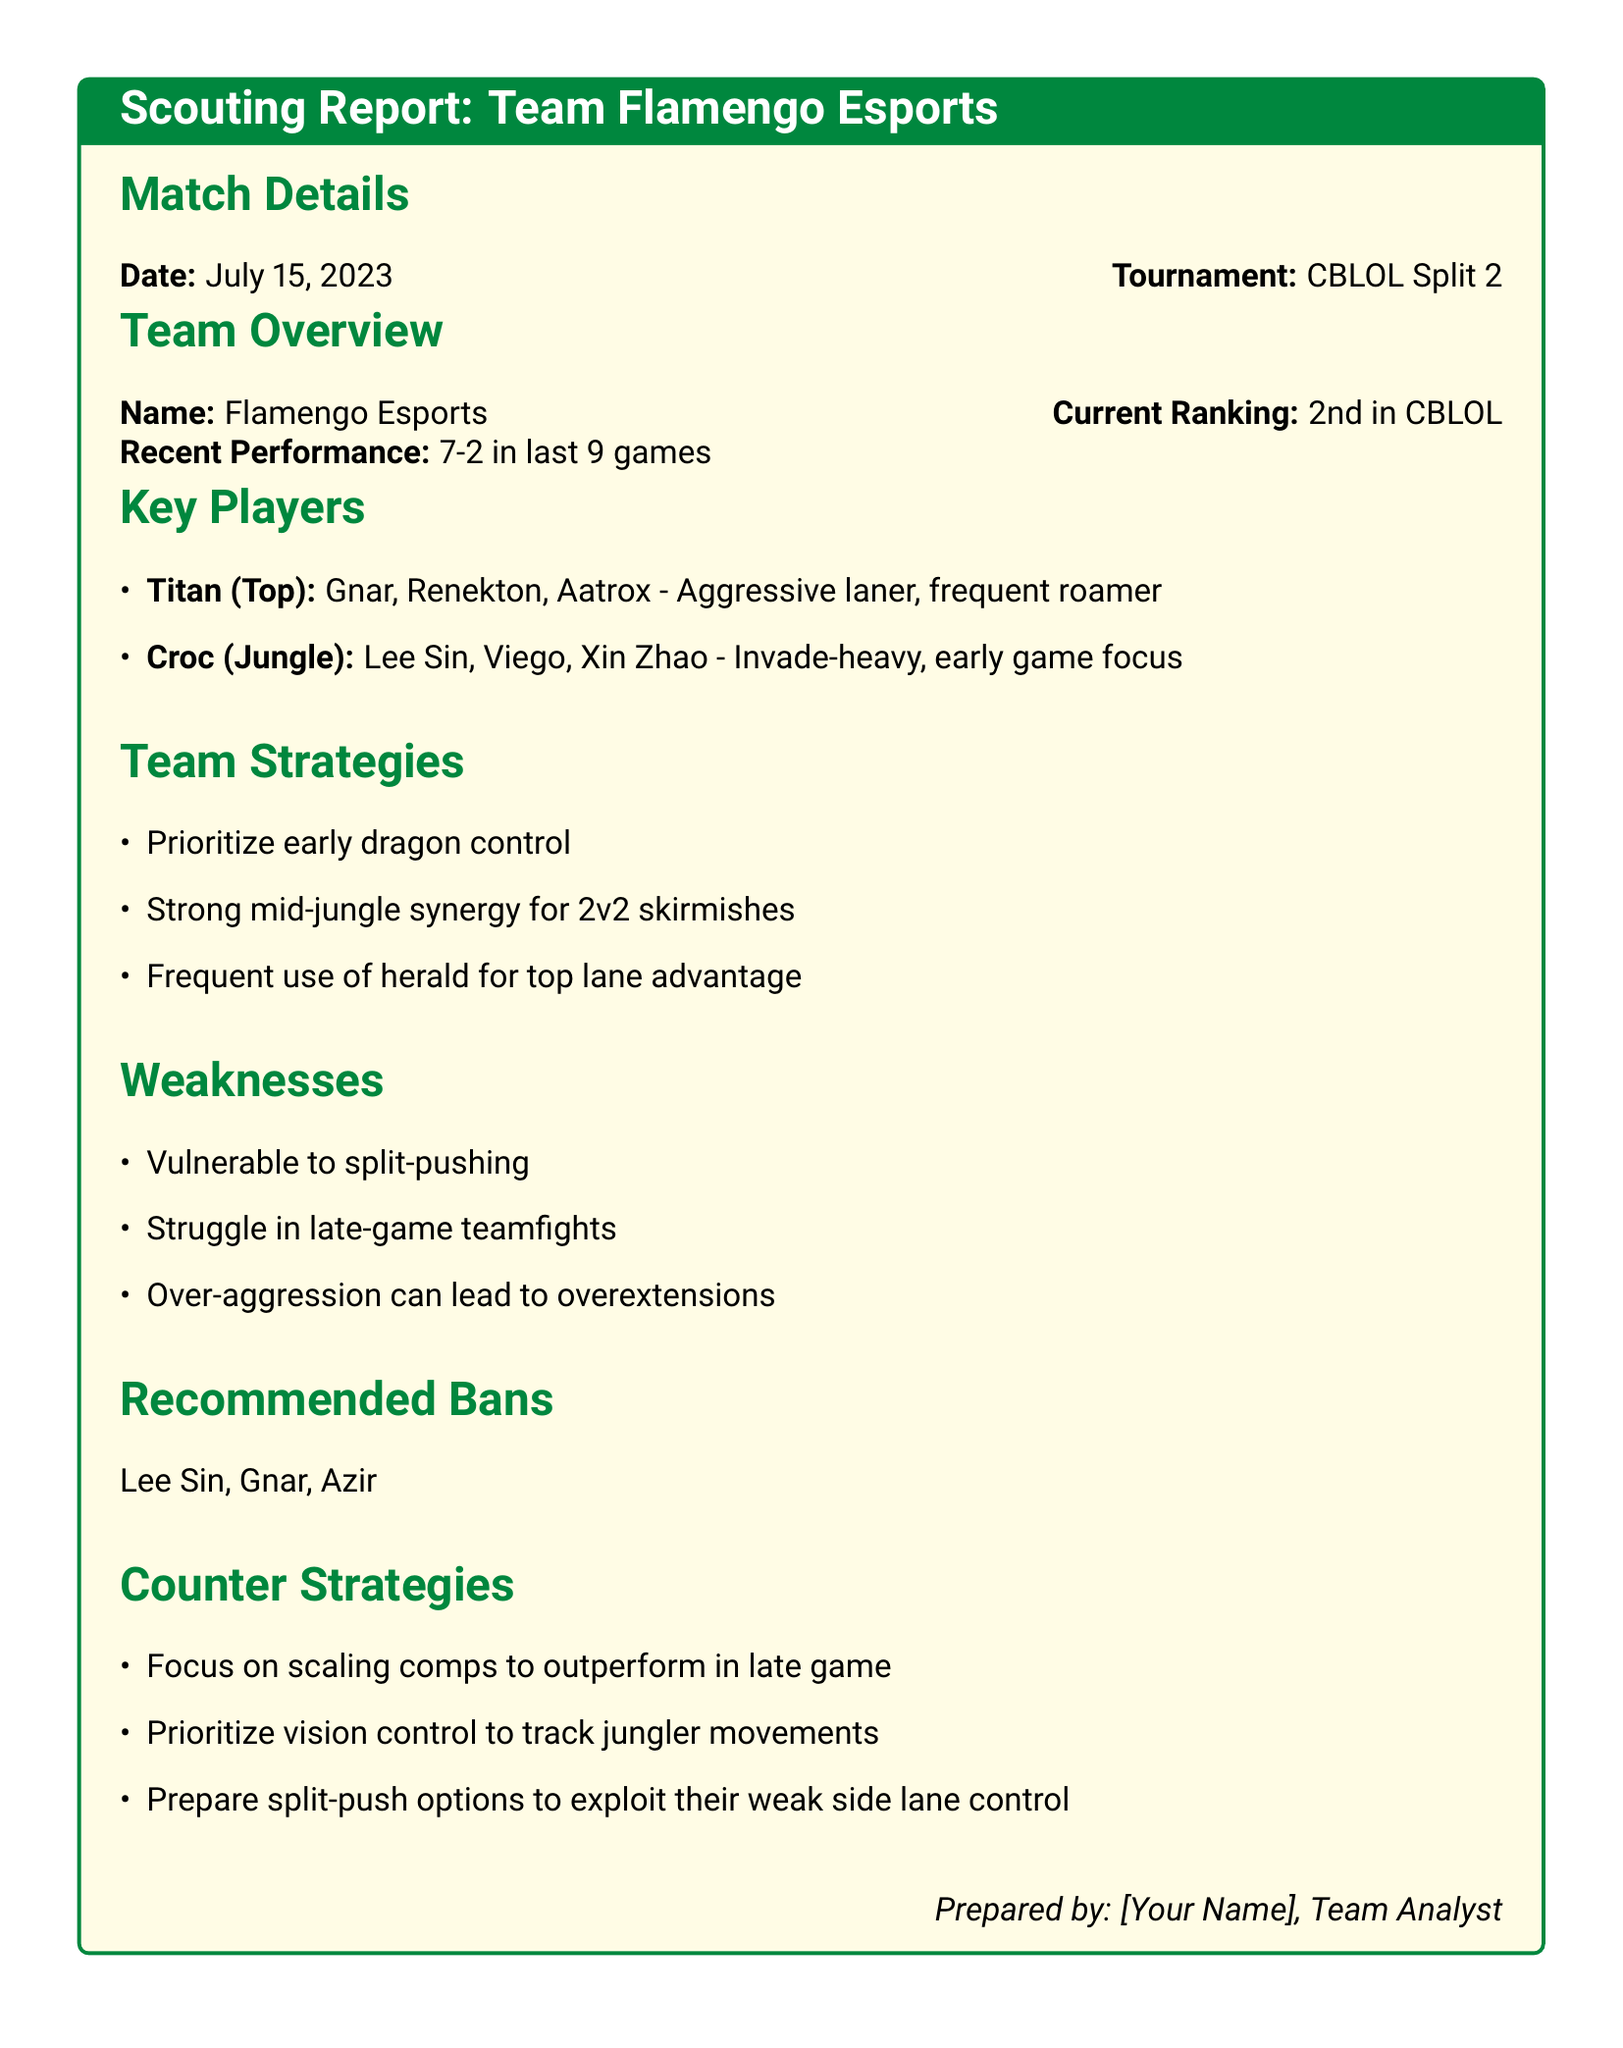What is the date of the match? The date of the match is specified in the match details section of the document.
Answer: July 15, 2023 Which team is the opponent? The team name is mentioned in the title of the scouting report.
Answer: Flamengo Esports What is the current ranking of Flamengo Esports? The ranking of the team is indicated in the team overview section.
Answer: 2nd in CBLOL Who is the jungler for Flamengo Esports? The key players section lists the roles and names of the players.
Answer: Croc What strategies does Flamengo Esports prioritize? The team strategies section lists the main strategies used by the team.
Answer: Early dragon control What is a noted weakness of Flamengo Esports? The weaknesses section highlights specific vulnerabilities of the team.
Answer: Vulnerable to split-pushing What should be banned against Flamengo Esports? The recommended bans section outlines players that should be banned.
Answer: Lee Sin, Gnar, Azir What type of compositions should counter Flamengo Esports? The counter strategies section suggests a particular type of strategy.
Answer: Scaling comps What champion has Titan been noted for? The key players section identifies the champions played by Titan.
Answer: Gnar What is Croc's primary focus in gameplay? The key players section describes the gameplay focus for Croc.
Answer: Early game focus 